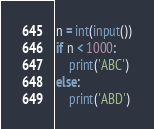<code> <loc_0><loc_0><loc_500><loc_500><_Python_>
n = int(input())
if n < 1000:
    print('ABC')
else:
    print('ABD')</code> 